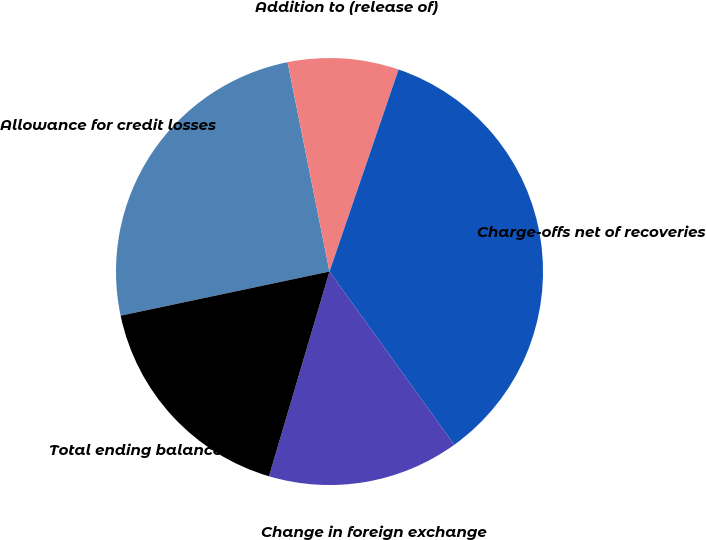Convert chart to OTSL. <chart><loc_0><loc_0><loc_500><loc_500><pie_chart><fcel>Allowance for credit losses<fcel>Addition to (release of)<fcel>Charge-offs net of recoveries<fcel>Change in foreign exchange<fcel>Total ending balance<nl><fcel>25.17%<fcel>8.39%<fcel>34.82%<fcel>14.51%<fcel>17.11%<nl></chart> 